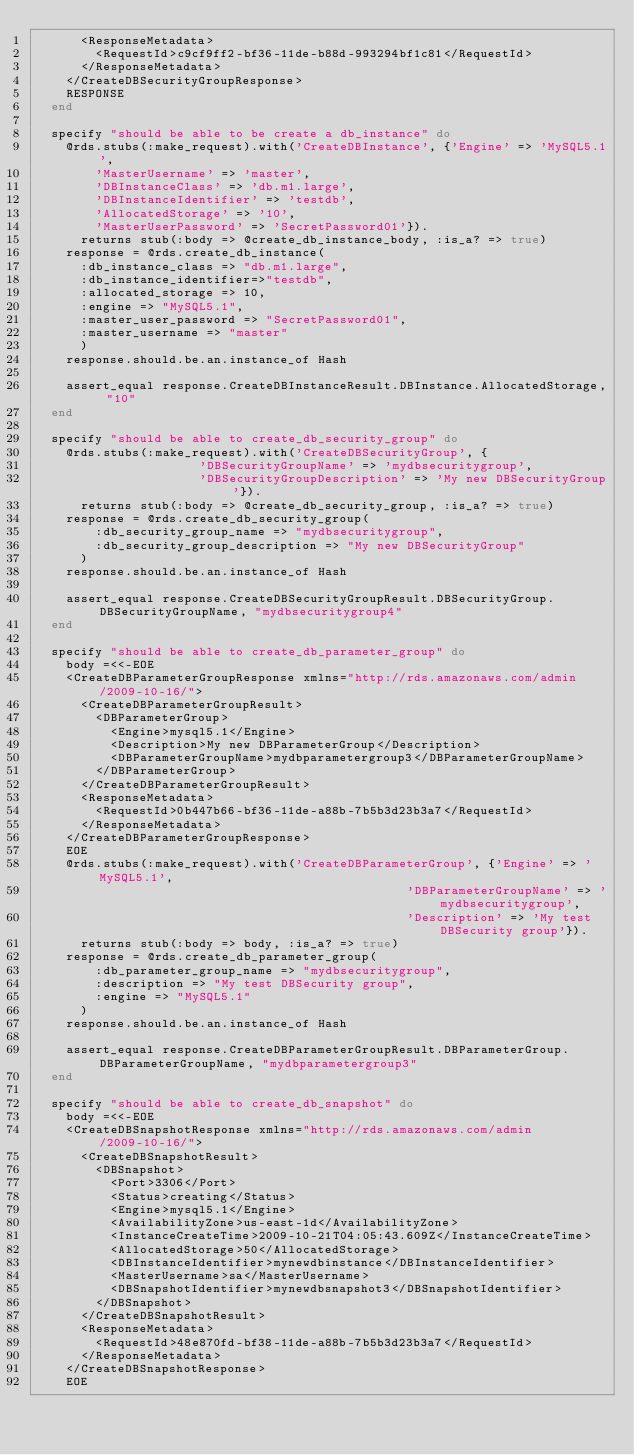Convert code to text. <code><loc_0><loc_0><loc_500><loc_500><_Ruby_>      <ResponseMetadata>
        <RequestId>c9cf9ff2-bf36-11de-b88d-993294bf1c81</RequestId>
      </ResponseMetadata>
    </CreateDBSecurityGroupResponse>
    RESPONSE
  end

  specify "should be able to be create a db_instance" do
    @rds.stubs(:make_request).with('CreateDBInstance', {'Engine' => 'MySQL5.1',
        'MasterUsername' => 'master',
        'DBInstanceClass' => 'db.m1.large',
        'DBInstanceIdentifier' => 'testdb',
        'AllocatedStorage' => '10',
        'MasterUserPassword' => 'SecretPassword01'}).
      returns stub(:body => @create_db_instance_body, :is_a? => true)
    response = @rds.create_db_instance(
      :db_instance_class => "db.m1.large",
      :db_instance_identifier=>"testdb",
      :allocated_storage => 10,
      :engine => "MySQL5.1",
      :master_user_password => "SecretPassword01",
      :master_username => "master"
      )
    response.should.be.an.instance_of Hash

    assert_equal response.CreateDBInstanceResult.DBInstance.AllocatedStorage, "10"
  end

  specify "should be able to create_db_security_group" do
    @rds.stubs(:make_request).with('CreateDBSecurityGroup', {
                      'DBSecurityGroupName' => 'mydbsecuritygroup',
                      'DBSecurityGroupDescription' => 'My new DBSecurityGroup'}).
      returns stub(:body => @create_db_security_group, :is_a? => true)
    response = @rds.create_db_security_group(
        :db_security_group_name => "mydbsecuritygroup",
        :db_security_group_description => "My new DBSecurityGroup"
      )
    response.should.be.an.instance_of Hash

    assert_equal response.CreateDBSecurityGroupResult.DBSecurityGroup.DBSecurityGroupName, "mydbsecuritygroup4"
  end

  specify "should be able to create_db_parameter_group" do
    body =<<-EOE
    <CreateDBParameterGroupResponse xmlns="http://rds.amazonaws.com/admin/2009-10-16/">
      <CreateDBParameterGroupResult>
        <DBParameterGroup>
          <Engine>mysql5.1</Engine>
          <Description>My new DBParameterGroup</Description>
          <DBParameterGroupName>mydbparametergroup3</DBParameterGroupName>
        </DBParameterGroup>
      </CreateDBParameterGroupResult>
      <ResponseMetadata>
        <RequestId>0b447b66-bf36-11de-a88b-7b5b3d23b3a7</RequestId>
      </ResponseMetadata>
    </CreateDBParameterGroupResponse>
    EOE
    @rds.stubs(:make_request).with('CreateDBParameterGroup', {'Engine' => 'MySQL5.1',
                                                  'DBParameterGroupName' => 'mydbsecuritygroup',
                                                  'Description' => 'My test DBSecurity group'}).
      returns stub(:body => body, :is_a? => true)
    response = @rds.create_db_parameter_group(
        :db_parameter_group_name => "mydbsecuritygroup",
        :description => "My test DBSecurity group",
        :engine => "MySQL5.1"
      )
    response.should.be.an.instance_of Hash

    assert_equal response.CreateDBParameterGroupResult.DBParameterGroup.DBParameterGroupName, "mydbparametergroup3"
  end

  specify "should be able to create_db_snapshot" do
    body =<<-EOE
    <CreateDBSnapshotResponse xmlns="http://rds.amazonaws.com/admin/2009-10-16/">
      <CreateDBSnapshotResult>
        <DBSnapshot>
          <Port>3306</Port>
          <Status>creating</Status>
          <Engine>mysql5.1</Engine>
          <AvailabilityZone>us-east-1d</AvailabilityZone>
          <InstanceCreateTime>2009-10-21T04:05:43.609Z</InstanceCreateTime>
          <AllocatedStorage>50</AllocatedStorage>
          <DBInstanceIdentifier>mynewdbinstance</DBInstanceIdentifier>
          <MasterUsername>sa</MasterUsername>
          <DBSnapshotIdentifier>mynewdbsnapshot3</DBSnapshotIdentifier>
        </DBSnapshot>
      </CreateDBSnapshotResult>
      <ResponseMetadata>
        <RequestId>48e870fd-bf38-11de-a88b-7b5b3d23b3a7</RequestId>
      </ResponseMetadata>
    </CreateDBSnapshotResponse>
    EOE</code> 